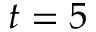Convert formula to latex. <formula><loc_0><loc_0><loc_500><loc_500>t = 5</formula> 